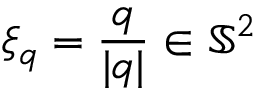Convert formula to latex. <formula><loc_0><loc_0><loc_500><loc_500>\xi _ { q } = \frac { q } { | q | } \in \mathbb { S } ^ { 2 }</formula> 